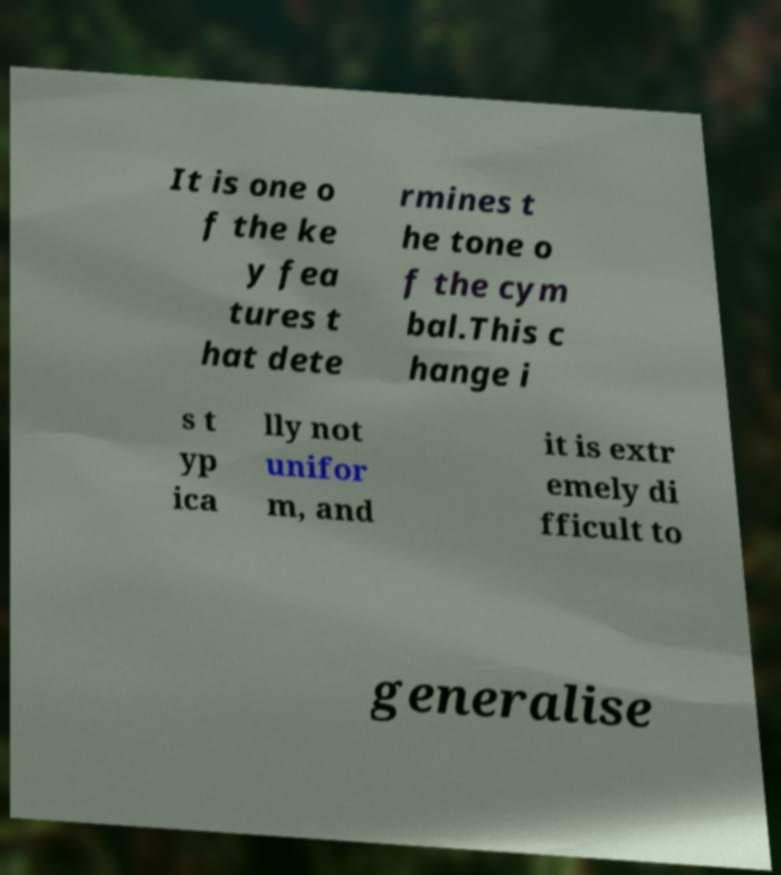Please read and relay the text visible in this image. What does it say? It is one o f the ke y fea tures t hat dete rmines t he tone o f the cym bal.This c hange i s t yp ica lly not unifor m, and it is extr emely di fficult to generalise 